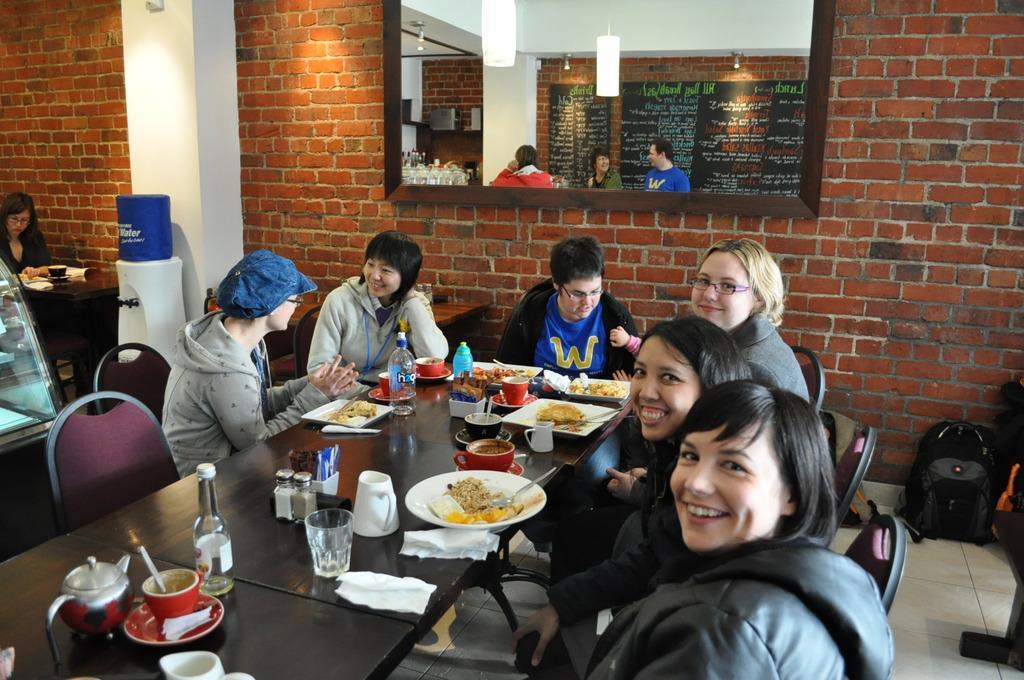Please provide a concise description of this image. This image is clicked in a restaurant. There are many people in this image. In the middle, there is a table on which there are bottles glasses and plates along with food. In the background, there is a wall to which a mirror is fixed. To the left, there is a filter along with water bubble. 